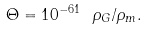<formula> <loc_0><loc_0><loc_500><loc_500>\Theta = 1 0 ^ { - 6 1 } \ \rho _ { G } / \rho _ { m } .</formula> 